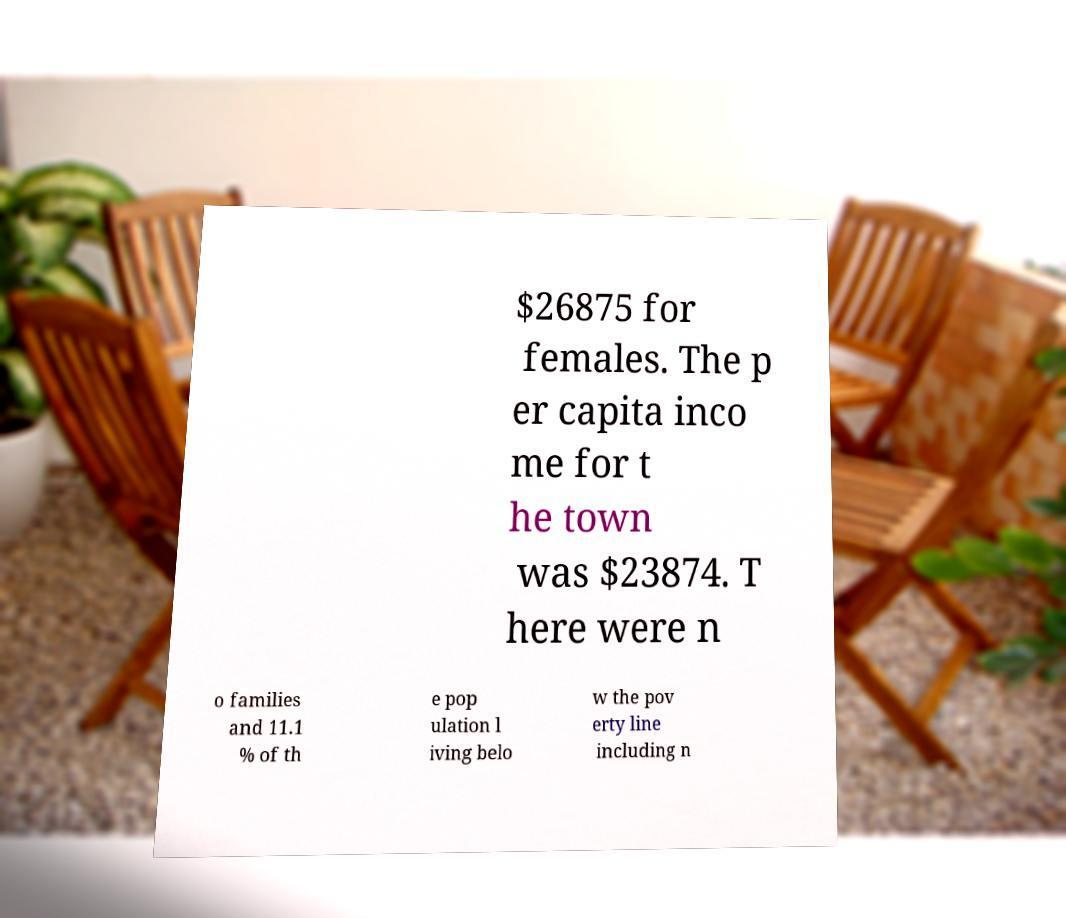For documentation purposes, I need the text within this image transcribed. Could you provide that? $26875 for females. The p er capita inco me for t he town was $23874. T here were n o families and 11.1 % of th e pop ulation l iving belo w the pov erty line including n 